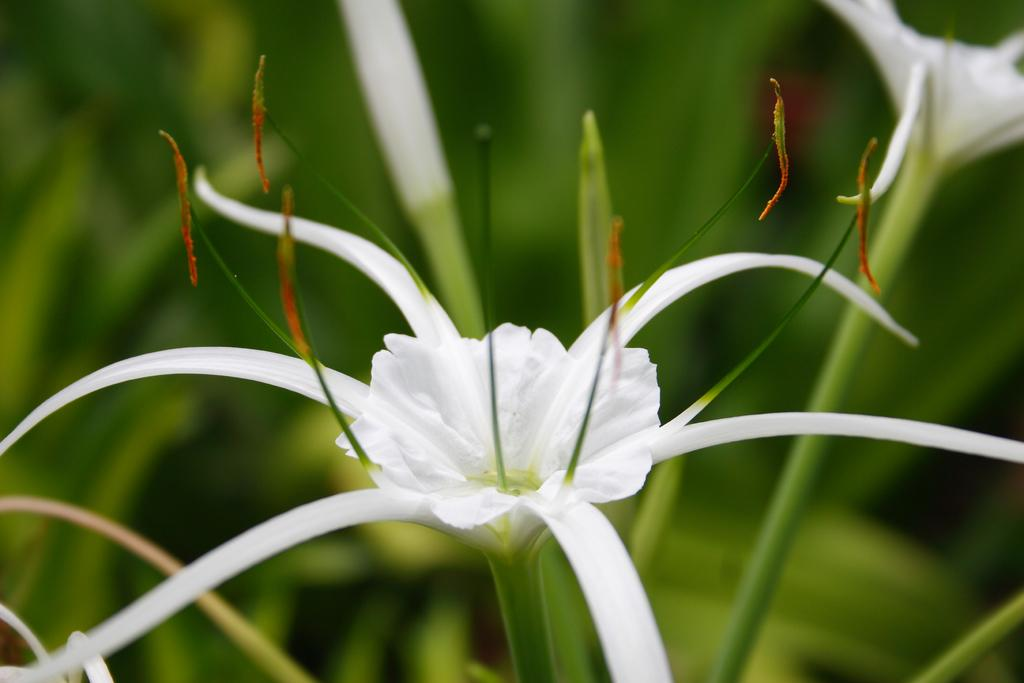What type of flowers can be seen in the image? There are white flowers with stems in the image. How would you describe the background of the image? The background of the image has a blurred view. What color is visible in the image? The color green is present in the image. What type of cloth is being used by the group in the image? There is no group or cloth present in the image; it features white flowers with stems and a blurred background. 